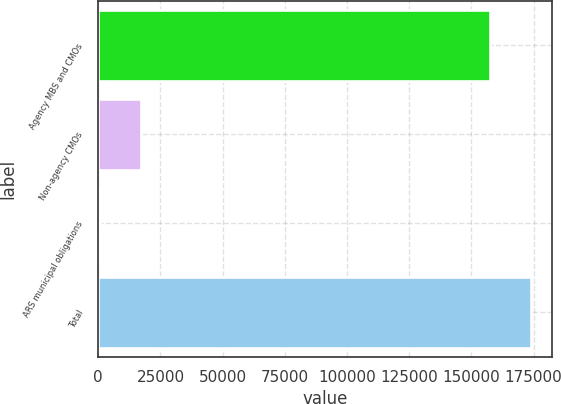<chart> <loc_0><loc_0><loc_500><loc_500><bar_chart><fcel>Agency MBS and CMOs<fcel>Non-agency CMOs<fcel>ARS municipal obligations<fcel>Total<nl><fcel>157580<fcel>17019.6<fcel>771<fcel>173829<nl></chart> 